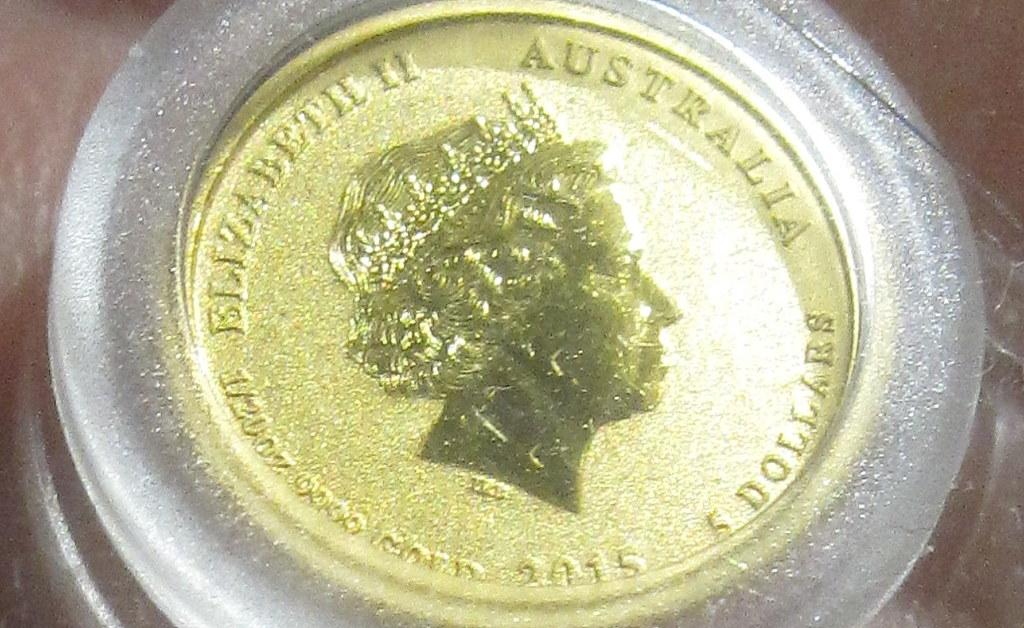<image>
Share a concise interpretation of the image provided. A gold coin from Australia in a clear case 